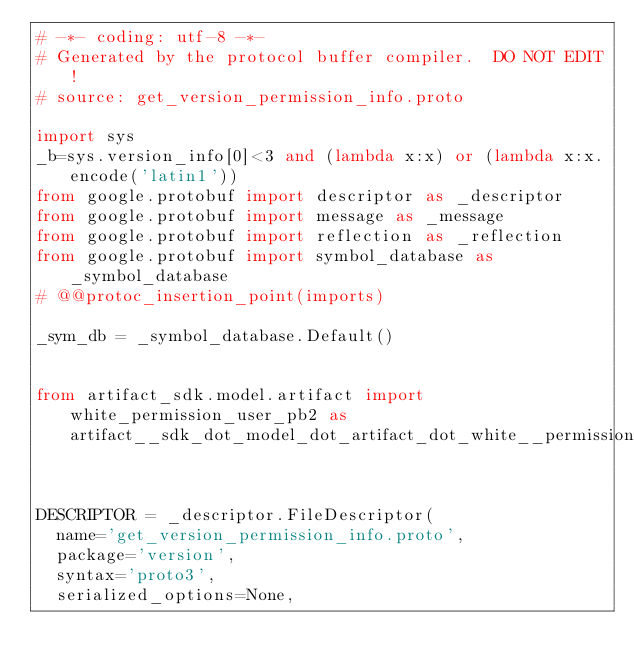<code> <loc_0><loc_0><loc_500><loc_500><_Python_># -*- coding: utf-8 -*-
# Generated by the protocol buffer compiler.  DO NOT EDIT!
# source: get_version_permission_info.proto

import sys
_b=sys.version_info[0]<3 and (lambda x:x) or (lambda x:x.encode('latin1'))
from google.protobuf import descriptor as _descriptor
from google.protobuf import message as _message
from google.protobuf import reflection as _reflection
from google.protobuf import symbol_database as _symbol_database
# @@protoc_insertion_point(imports)

_sym_db = _symbol_database.Default()


from artifact_sdk.model.artifact import white_permission_user_pb2 as artifact__sdk_dot_model_dot_artifact_dot_white__permission__user__pb2


DESCRIPTOR = _descriptor.FileDescriptor(
  name='get_version_permission_info.proto',
  package='version',
  syntax='proto3',
  serialized_options=None,</code> 